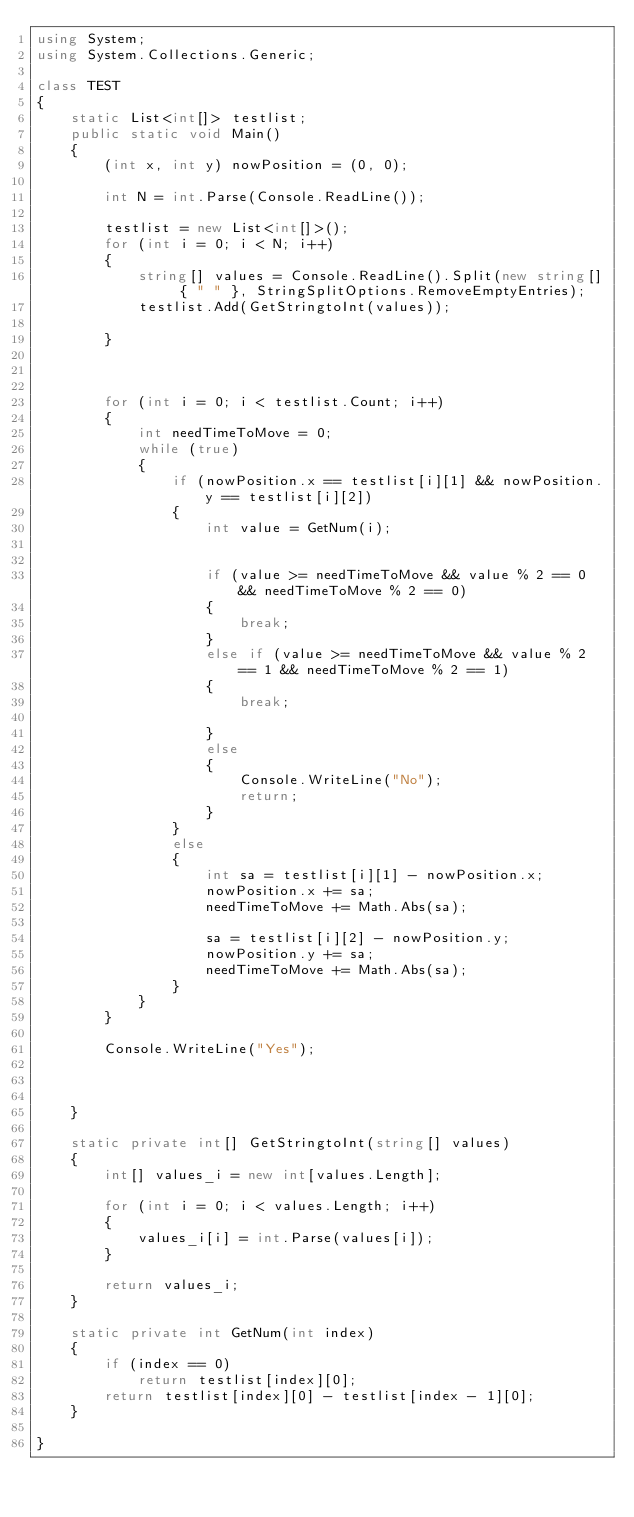Convert code to text. <code><loc_0><loc_0><loc_500><loc_500><_C#_>using System;
using System.Collections.Generic;

class TEST
{
    static List<int[]> testlist;
    public static void Main()
    {
        (int x, int y) nowPosition = (0, 0);

        int N = int.Parse(Console.ReadLine());

        testlist = new List<int[]>();
        for (int i = 0; i < N; i++)
        {
            string[] values = Console.ReadLine().Split(new string[] { " " }, StringSplitOptions.RemoveEmptyEntries);
            testlist.Add(GetStringtoInt(values));

        }



        for (int i = 0; i < testlist.Count; i++)
        {
            int needTimeToMove = 0;
            while (true)
            {
                if (nowPosition.x == testlist[i][1] && nowPosition.y == testlist[i][2])
                {
                    int value = GetNum(i);

                   
                    if (value >= needTimeToMove && value % 2 == 0 && needTimeToMove % 2 == 0)
                    {
                        break;
                    }
                    else if (value >= needTimeToMove && value % 2 == 1 && needTimeToMove % 2 == 1)
                    {
                        break;

                    }
                    else
                    {
                        Console.WriteLine("No");
                        return;
                    }
                }
                else
                {
                    int sa = testlist[i][1] - nowPosition.x;
                    nowPosition.x += sa;
                    needTimeToMove += Math.Abs(sa);

                    sa = testlist[i][2] - nowPosition.y;
                    nowPosition.y += sa;
                    needTimeToMove += Math.Abs(sa);
                }
            }
        }

        Console.WriteLine("Yes");



    }

    static private int[] GetStringtoInt(string[] values)
    {
        int[] values_i = new int[values.Length];

        for (int i = 0; i < values.Length; i++)
        {
            values_i[i] = int.Parse(values[i]);
        }

        return values_i;
    }

    static private int GetNum(int index)
    {
        if (index == 0)
            return testlist[index][0];
        return testlist[index][0] - testlist[index - 1][0];
    }

}</code> 